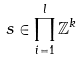Convert formula to latex. <formula><loc_0><loc_0><loc_500><loc_500>s \in \prod _ { i = 1 } ^ { l } \mathbb { Z } ^ { k }</formula> 